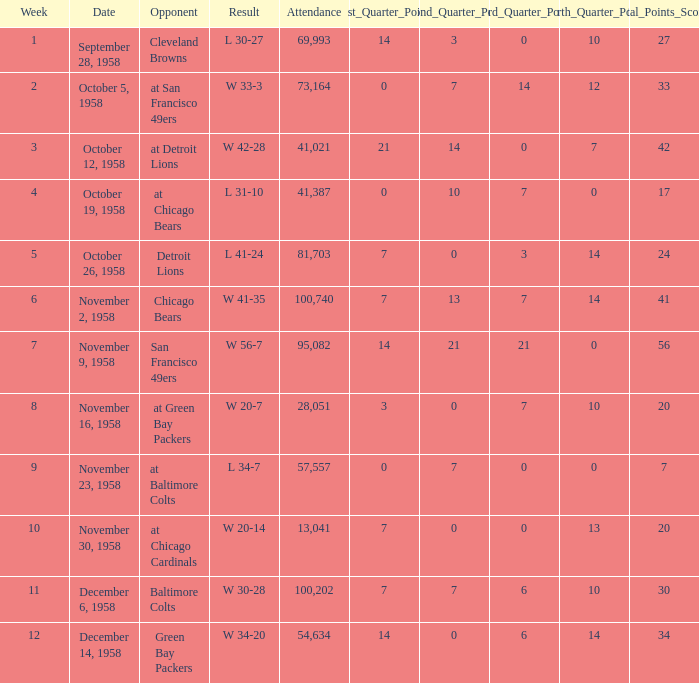What was the higest attendance on November 9, 1958? 95082.0. 